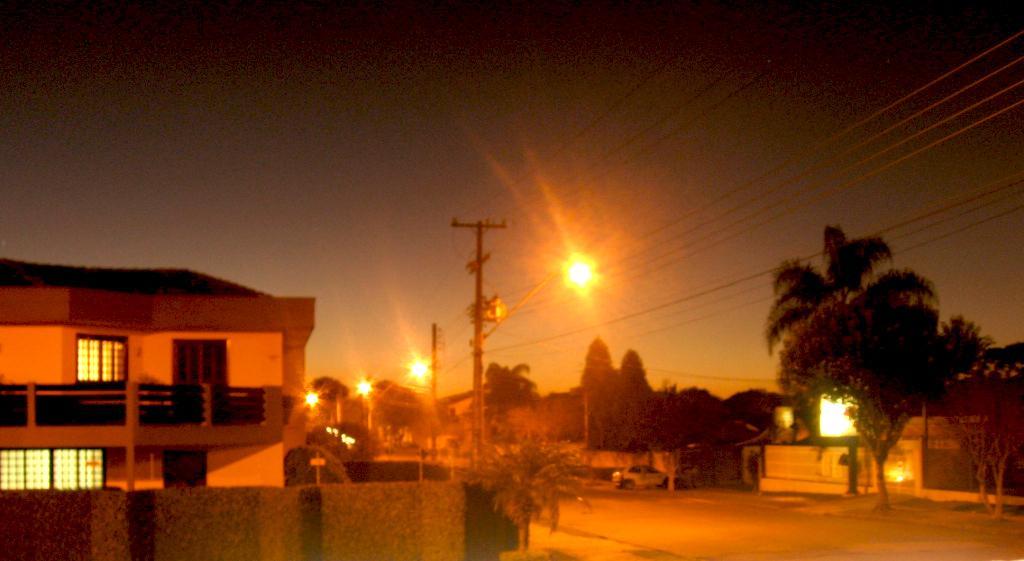Could you give a brief overview of what you see in this image? In this image there is a road. Also there are trees. And there are electric poles with wires. There are light poles. On the left side there is a building with windows. And there is a compound wall. In the background there is sky. Also we can see a vehicle in the back. 